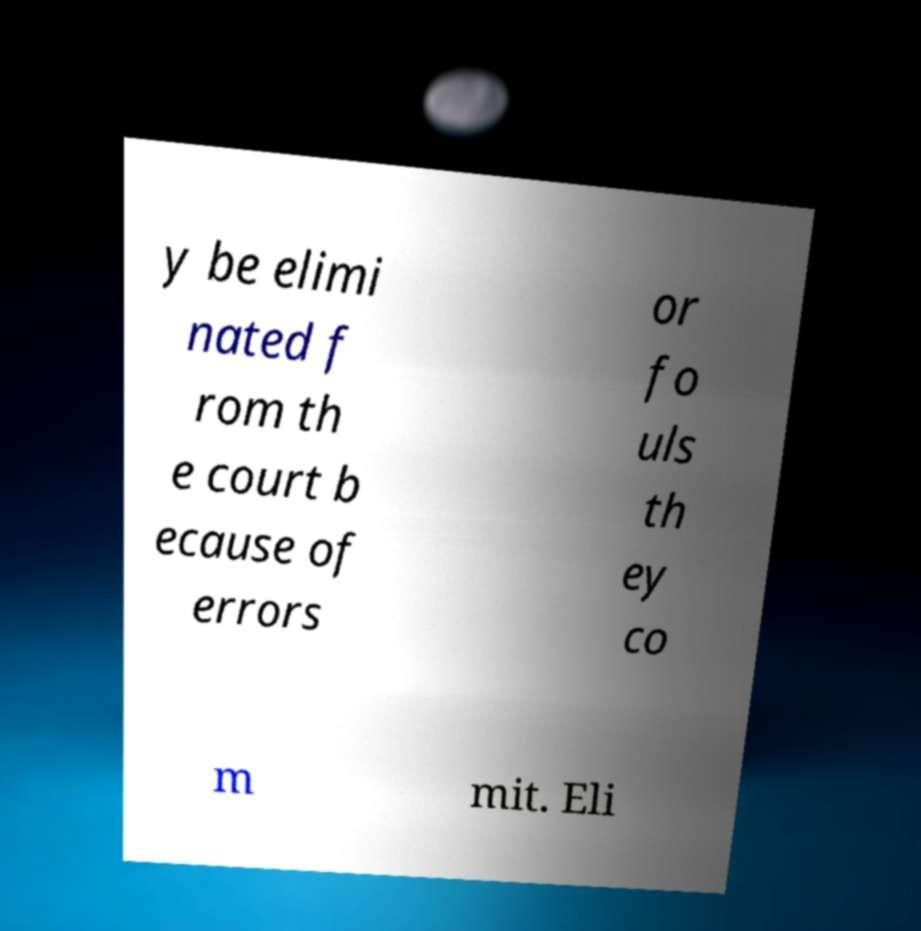Could you assist in decoding the text presented in this image and type it out clearly? y be elimi nated f rom th e court b ecause of errors or fo uls th ey co m mit. Eli 